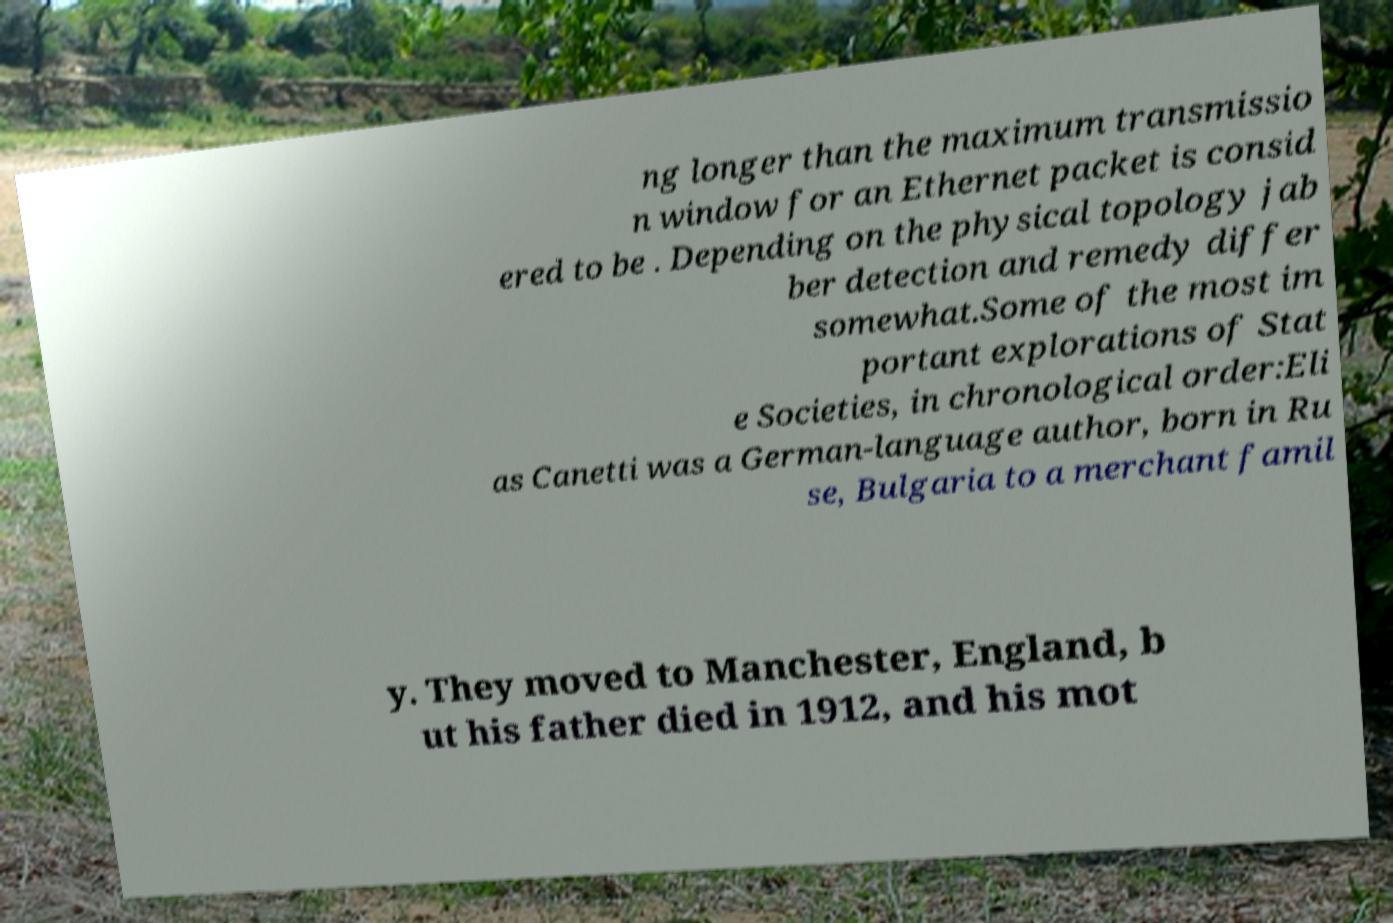Please read and relay the text visible in this image. What does it say? ng longer than the maximum transmissio n window for an Ethernet packet is consid ered to be . Depending on the physical topology jab ber detection and remedy differ somewhat.Some of the most im portant explorations of Stat e Societies, in chronological order:Eli as Canetti was a German-language author, born in Ru se, Bulgaria to a merchant famil y. They moved to Manchester, England, b ut his father died in 1912, and his mot 